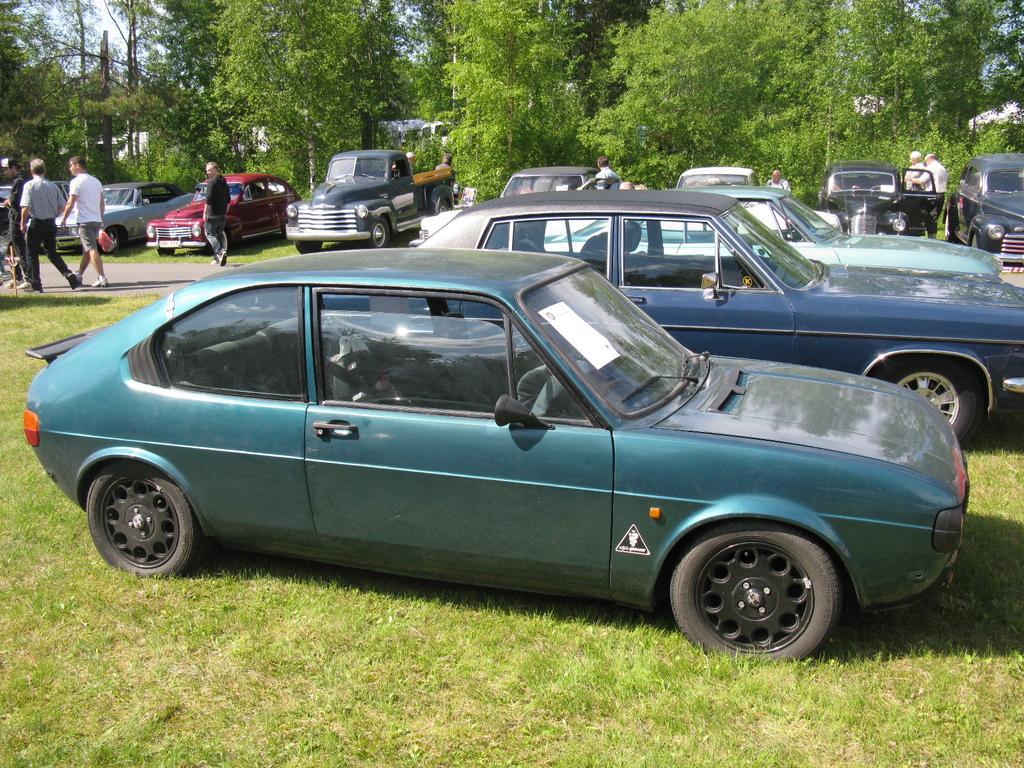Describe this image in one or two sentences. In this image we can see some vehicles, persons and other objects. In the background of the image there are trees, sky and other objects. At the bottom of the image there is the grass. 